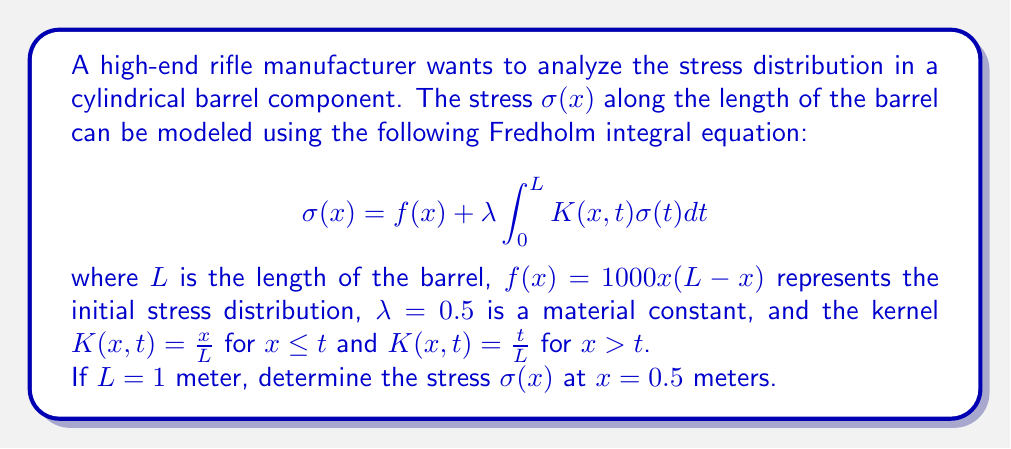Can you answer this question? To solve this Fredholm integral equation, we'll use the method of successive approximations:

1) Start with the initial approximation $\sigma_0(x) = f(x) = 1000x(1-x)$

2) Use the recurrence relation:
   $$\sigma_{n+1}(x) = f(x) + \lambda \int_0^L K(x,t)\sigma_n(t)dt$$

3) For $x = 0.5$, we need to split the integral:
   $$\sigma_{n+1}(0.5) = f(0.5) + 0.5 \left(\int_0^{0.5} \frac{0.5}{1}σ_n(t)dt + \int_{0.5}^1 \frac{t}{1}σ_n(t)dt\right)$$

4) First iteration:
   $$\begin{align*}
   \sigma_1(0.5) &= 1000(0.5)(0.5) + 0.5 \left(0.5\int_0^{0.5} 1000t(1-t)dt + \int_{0.5}^1 1000t^2(1-t)dt\right) \\
   &= 250 + 0.5(0.5 \cdot 31.25 + 62.5) \\
   &= 250 + 39.0625 = 289.0625
   \end{align*}$$

5) Second iteration:
   $$\begin{align*}
   \sigma_2(0.5) &≈ 250 + 0.5(0.5 \cdot 36.13 + 72.26) \\
   &≈ 250 + 45.16 = 295.16
   \end{align*}$$

6) Third iteration:
   $$\begin{align*}
   \sigma_3(0.5) &≈ 250 + 0.5(0.5 \cdot 36.895 + 73.79) \\
   &≈ 250 + 46.12 = 296.12
   \end{align*}$$

The solution converges quickly, so we can stop here.
Answer: $\sigma(0.5) \approx 296.12$ N/m² 